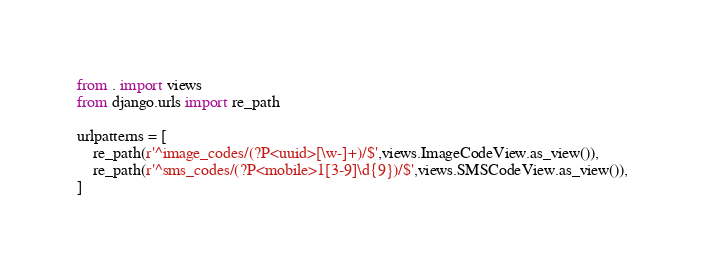Convert code to text. <code><loc_0><loc_0><loc_500><loc_500><_Python_>
from . import views
from django.urls import re_path

urlpatterns = [
    re_path(r'^image_codes/(?P<uuid>[\w-]+)/$',views.ImageCodeView.as_view()),
    re_path(r'^sms_codes/(?P<mobile>1[3-9]\d{9})/$',views.SMSCodeView.as_view()),
]</code> 